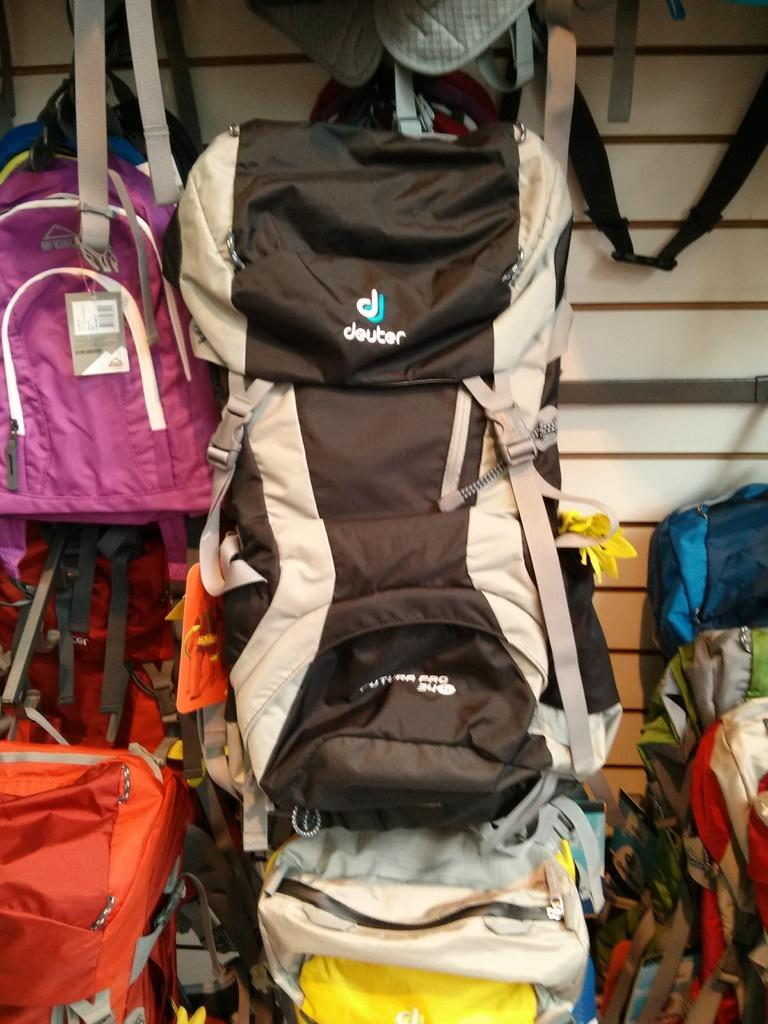<image>
Give a short and clear explanation of the subsequent image. A Deuter brand backpack hangs on the wall in a store. 